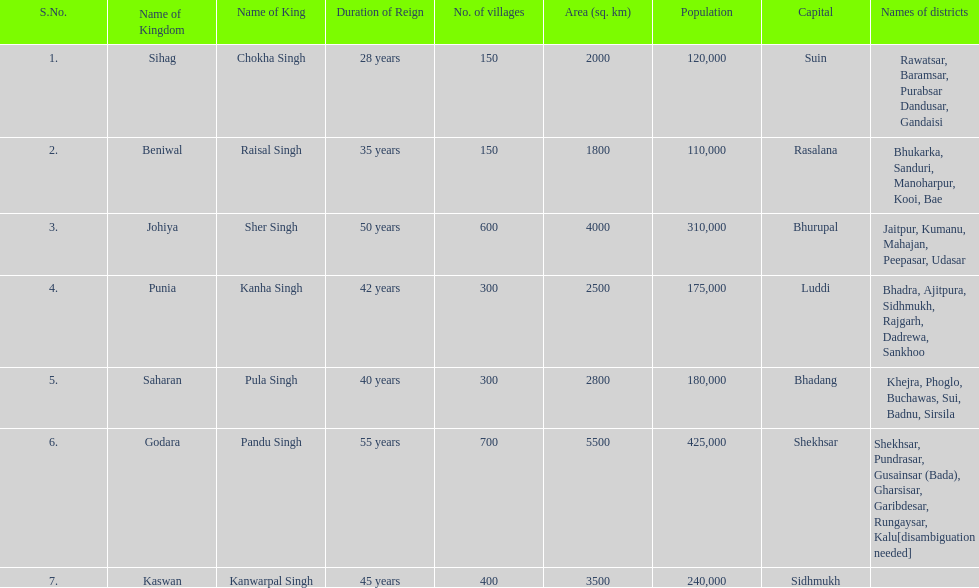What is the next kingdom listed after sihag? Beniwal. I'm looking to parse the entire table for insights. Could you assist me with that? {'header': ['S.No.', 'Name of Kingdom', 'Name of King', 'Duration of Reign', 'No. of villages', 'Area (sq. km)', 'Population', 'Capital', 'Names of districts'], 'rows': [['1.', 'Sihag', 'Chokha Singh', '28 years', '150', '2000', '120,000', 'Suin', 'Rawatsar, Baramsar, Purabsar Dandusar, Gandaisi'], ['2.', 'Beniwal', 'Raisal Singh', '35 years', '150', '1800', '110,000', 'Rasalana', 'Bhukarka, Sanduri, Manoharpur, Kooi, Bae'], ['3.', 'Johiya', 'Sher Singh', '50 years', '600', '4000', '310,000', 'Bhurupal', 'Jaitpur, Kumanu, Mahajan, Peepasar, Udasar'], ['4.', 'Punia', 'Kanha Singh', '42 years', '300', '2500', '175,000', 'Luddi', 'Bhadra, Ajitpura, Sidhmukh, Rajgarh, Dadrewa, Sankhoo'], ['5.', 'Saharan', 'Pula Singh', '40 years', '300', '2800', '180,000', 'Bhadang', 'Khejra, Phoglo, Buchawas, Sui, Badnu, Sirsila'], ['6.', 'Godara', 'Pandu Singh', '55 years', '700', '5500', '425,000', 'Shekhsar', 'Shekhsar, Pundrasar, Gusainsar (Bada), Gharsisar, Garibdesar, Rungaysar, Kalu[disambiguation needed]'], ['7.', 'Kaswan', 'Kanwarpal Singh', '45 years', '400', '3500', '240,000', 'Sidhmukh', '']]} 